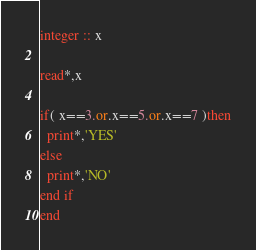<code> <loc_0><loc_0><loc_500><loc_500><_FORTRAN_>integer :: x

read*,x

if( x==3.or.x==5.or.x==7 )then
  print*,'YES'
else
  print*,'NO'
end if
end
</code> 